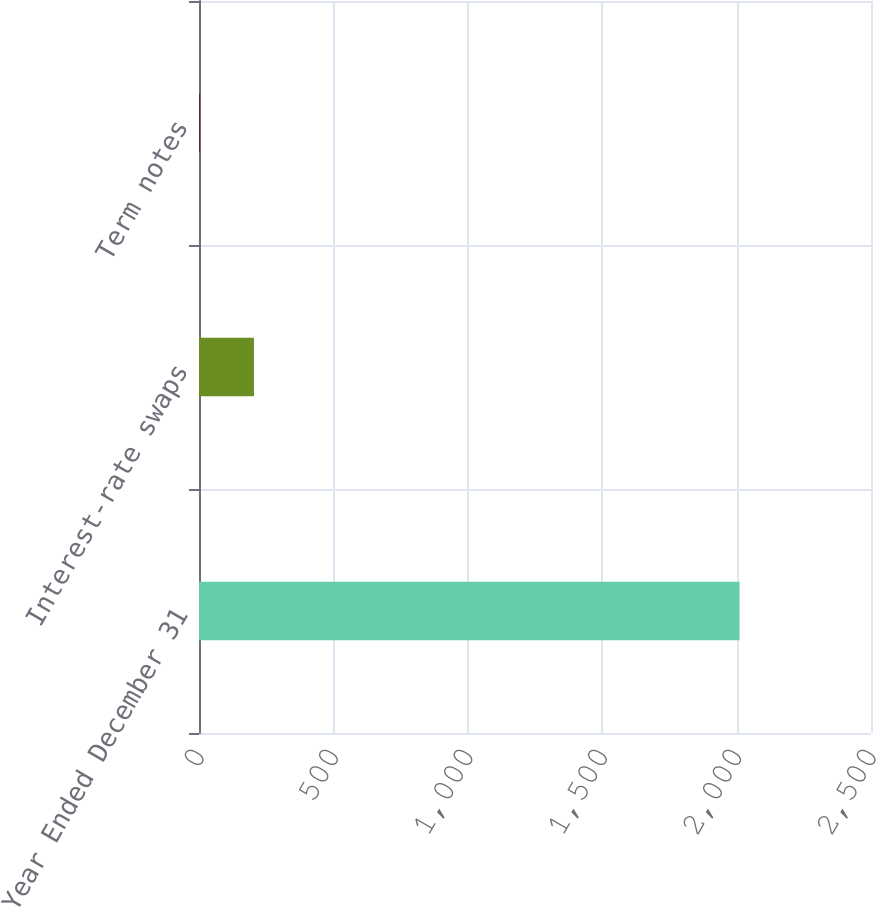Convert chart to OTSL. <chart><loc_0><loc_0><loc_500><loc_500><bar_chart><fcel>Year Ended December 31<fcel>Interest-rate swaps<fcel>Term notes<nl><fcel>2011<fcel>204.43<fcel>3.7<nl></chart> 